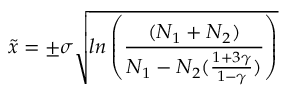Convert formula to latex. <formula><loc_0><loc_0><loc_500><loc_500>\tilde { x } = \pm \sigma \sqrt { \ln \left ( \frac { ( N _ { 1 } + N _ { 2 } ) } { N _ { 1 } - N _ { 2 } ( \frac { 1 + 3 \gamma } { 1 - \gamma } ) } \right ) }</formula> 